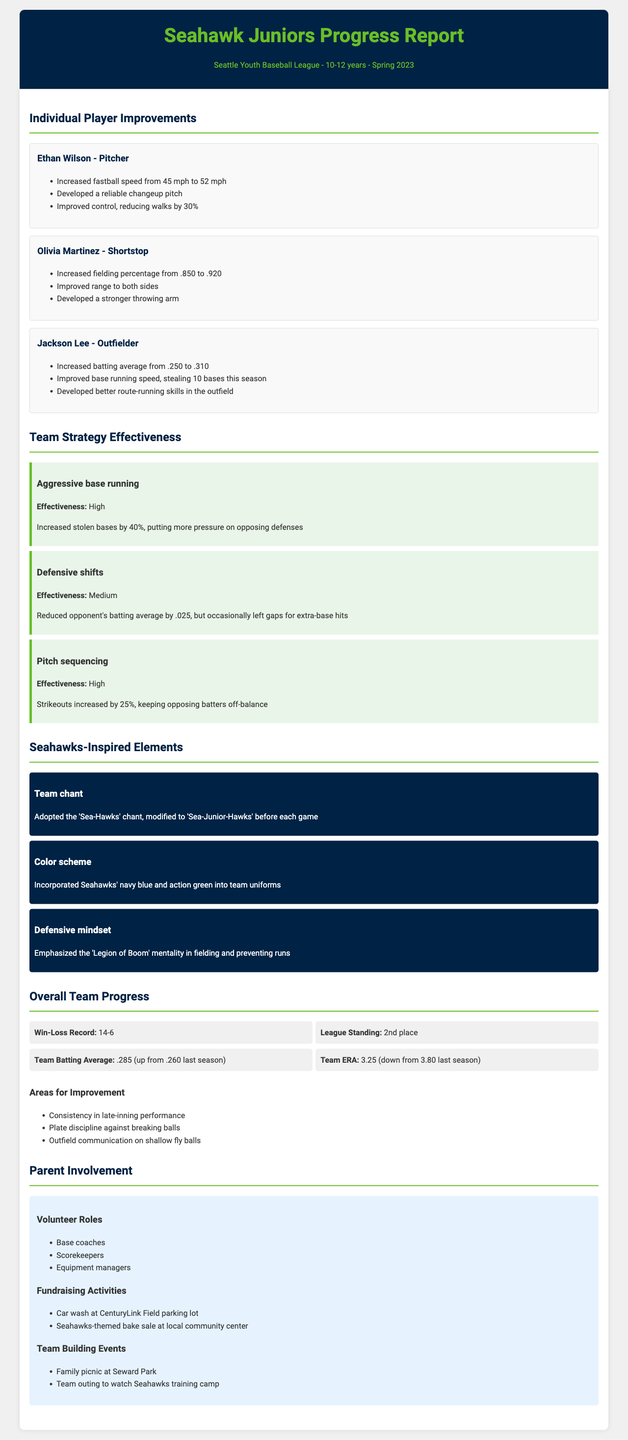What is the team's win-loss record? The win-loss record is a statistic representing the number of games won and lost by the team during the season, which is detailed in the overall team progress section.
Answer: 14-6 Who is the pitcher mentioned in player improvements? This question requires identifying a specific player under the individual player improvements section based on their position.
Answer: Ethan Wilson What is the team batting average this season? The team batting average is a statistic reflecting the overall hitting performance of the team, as mentioned in the overall team progress section.
Answer: .285 How many bases did Jackson Lee steal this season? This question focuses on the individual player's achievements as highlighted in the player improvements.
Answer: 10 What strategy had a high effectiveness rating? This question is about evaluating the effectiveness of different team strategies outlined in the report.
Answer: Aggressive base running What is the current league standing of the Seahawk Juniors? This question pertains to the team's position in the league context, found in the overall team progress section of the document.
Answer: 2nd place What volunteer role is listed first under parent involvement? This question asks for specific information from the parent involvement section focusing on the roles available for parents.
Answer: Base coaches Which element emphasizes the "Legion of Boom" mentality? This question examines the Seahawks-inspired elements section for specific mindset adoption during gameplay.
Answer: Defensive mindset What is an area for improvement noted in the report? This question evaluates the document for areas where the team needs to enhance its performance.
Answer: Consistency in late-inning performance 